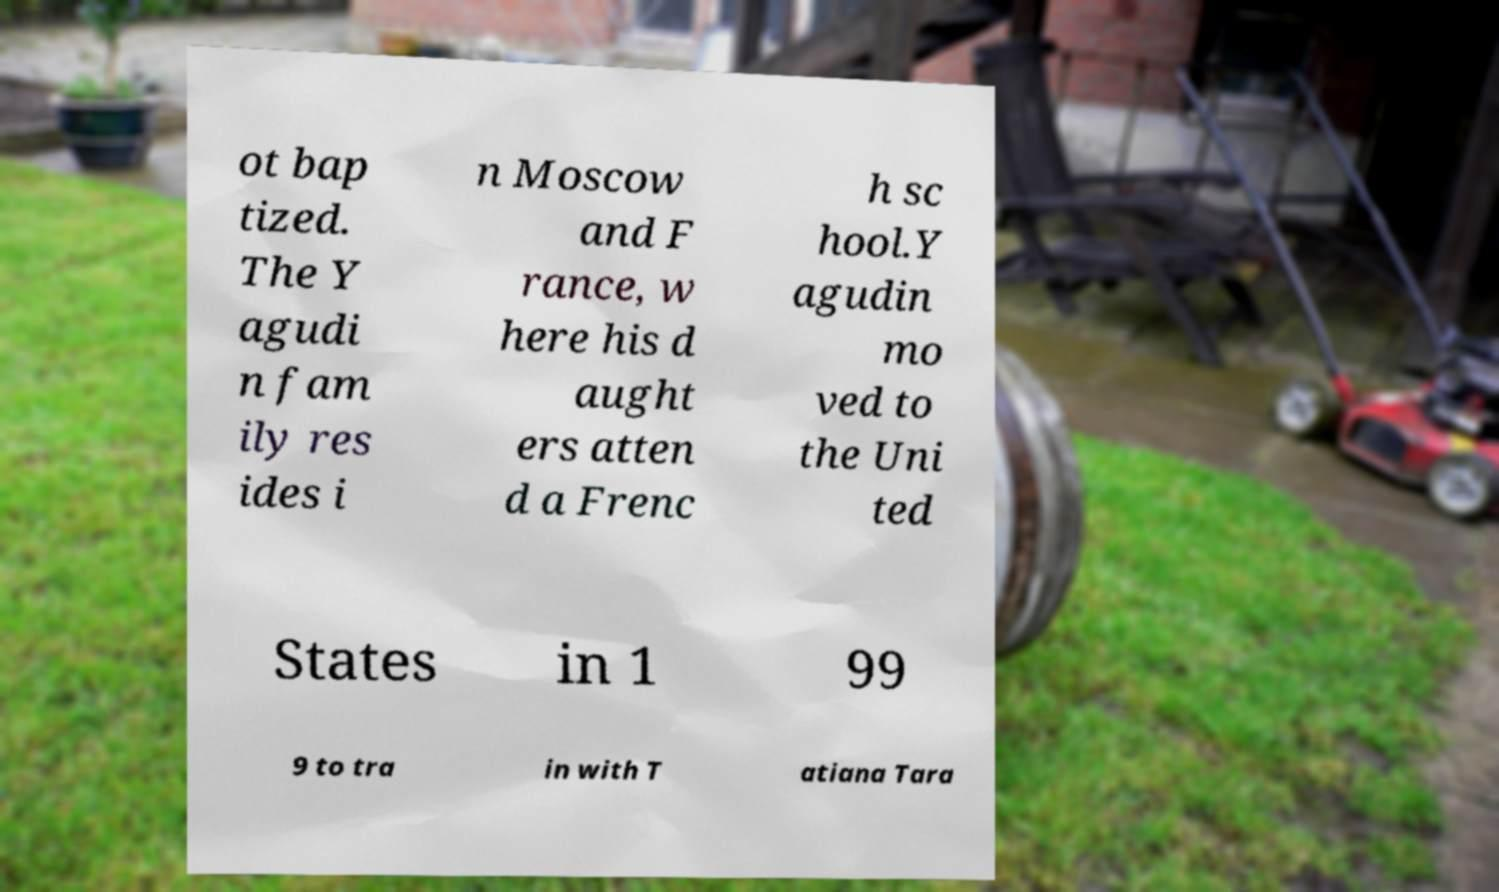Please read and relay the text visible in this image. What does it say? ot bap tized. The Y agudi n fam ily res ides i n Moscow and F rance, w here his d aught ers atten d a Frenc h sc hool.Y agudin mo ved to the Uni ted States in 1 99 9 to tra in with T atiana Tara 